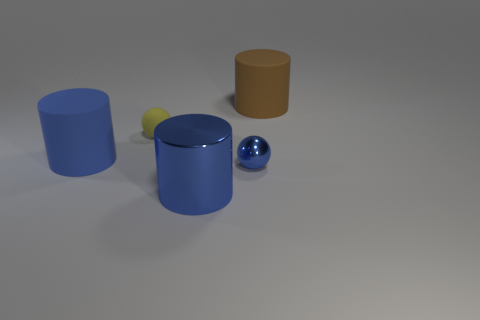What is the size of the rubber cylinder that is the same color as the metal ball?
Make the answer very short. Large. What number of yellow objects are small matte cylinders or metallic cylinders?
Offer a very short reply. 0. What number of other things are there of the same shape as the blue rubber object?
Provide a short and direct response. 2. The large object that is both behind the metal ball and on the left side of the tiny blue metal thing has what shape?
Your answer should be very brief. Cylinder. Are there any big brown rubber objects right of the shiny sphere?
Make the answer very short. Yes. There is a blue matte object that is the same shape as the brown matte thing; what is its size?
Your response must be concise. Large. Is there anything else that is the same size as the brown matte object?
Offer a very short reply. Yes. Do the yellow thing and the small shiny thing have the same shape?
Your response must be concise. Yes. There is a object that is to the left of the ball to the left of the blue metallic cylinder; what is its size?
Your answer should be compact. Large. What is the color of the other rubber object that is the same shape as the blue rubber object?
Your response must be concise. Brown. 